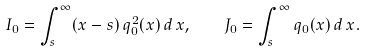Convert formula to latex. <formula><loc_0><loc_0><loc_500><loc_500>I _ { 0 } = \int _ { s } ^ { \infty } ( x - s ) \, q _ { 0 } ^ { 2 } ( x ) \, d \, x , \quad J _ { 0 } = \int _ { s } ^ { \infty } q _ { 0 } ( x ) \, d \, x .</formula> 